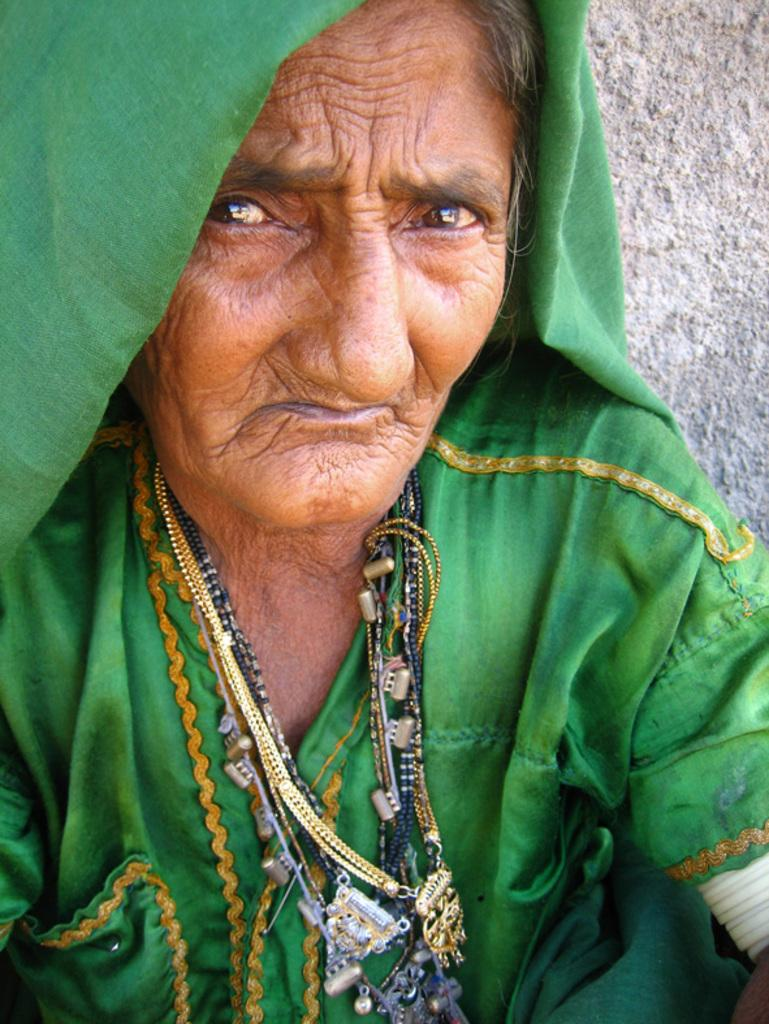What is the main subject of the image? There is a person in the image. What can be seen in the background of the image? There is a wall in the background of the image. What type of straw is the person using to fix the clock in the image? There is no straw or clock present in the image. 